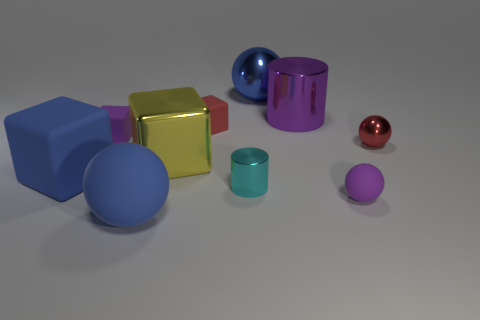How many tiny things are brown rubber things or blue blocks?
Provide a short and direct response. 0. The other big matte thing that is the same shape as the large yellow object is what color?
Your response must be concise. Blue. Is the size of the red matte object the same as the blue block?
Give a very brief answer. No. What number of objects are either big purple cylinders or rubber cubes that are on the left side of the tiny red block?
Offer a very short reply. 3. The small matte block that is right of the rubber ball in front of the tiny purple rubber ball is what color?
Give a very brief answer. Red. Do the metallic cylinder to the right of the blue metal ball and the small matte ball have the same color?
Provide a succinct answer. Yes. What is the material of the cyan cylinder left of the big purple object?
Keep it short and to the point. Metal. The red shiny ball is what size?
Your answer should be compact. Small. Are the tiny red thing that is right of the big blue shiny object and the big yellow cube made of the same material?
Provide a short and direct response. Yes. How many yellow metallic blocks are there?
Offer a terse response. 1. 